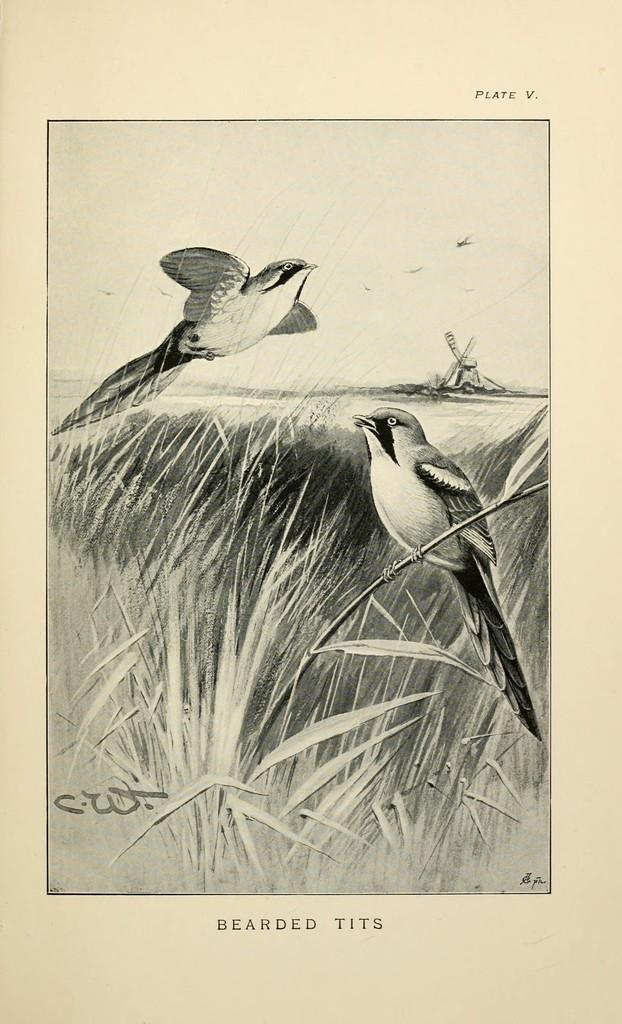What type of animals can be seen in the image? Birds can be seen in the image. What other elements are present in the image besides the birds? There are plants in the image. Is there any text present in the image? Yes, there is text written at the bottom of the image. What type of learning can be observed in the image? There is no learning activity present in the image; it features birds and plants. Can you see a match being lit in the image? There is no match or any indication of fire in the image. 